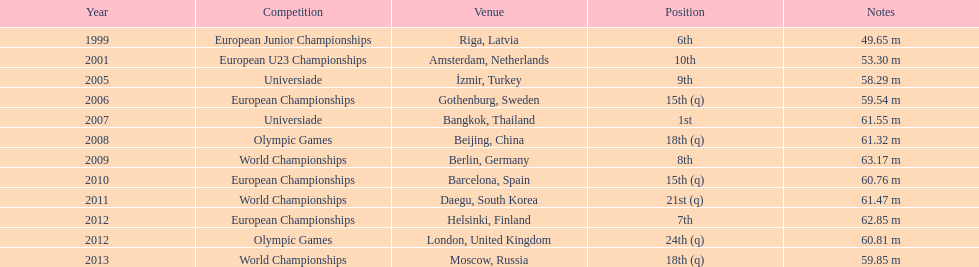What was the longest throw mayer ever achieved as his top result? 63.17 m. 